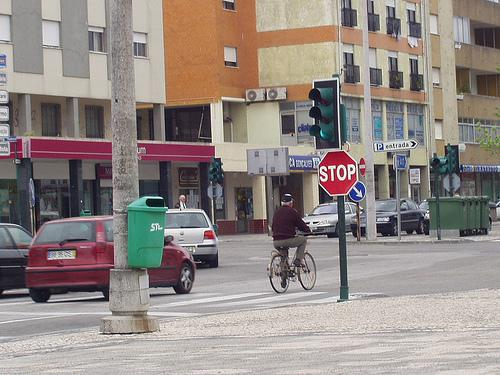Question: who is riding a bike?
Choices:
A. Older man.
B. A Clown.
C. The boy.
D. The little girl.
Answer with the letter. Answer: A Question: where is the green garbage can?
Choices:
A. In the air.
B. In the drive-way.
C. On the utility pole.
D. On the sidewalk.
Answer with the letter. Answer: C Question: what color is the car to the left of the utility pole?
Choices:
A. Blue.
B. White.
C. Silver.
D. Maroon.
Answer with the letter. Answer: D Question: what is green?
Choices:
A. The traffic signs.
B. Stop light.
C. The street sign.
D. The storage shed.
Answer with the letter. Answer: B Question: where are the green dumpsters?
Choices:
A. Behind the building.
B. Beside the cafeteria.
C. Around the side of the barn.
D. Right side of blue car.
Answer with the letter. Answer: D Question: what is red and white?
Choices:
A. The banner.
B. Stop sign.
C. The yard sale sign.
D. The mailbox.
Answer with the letter. Answer: B 